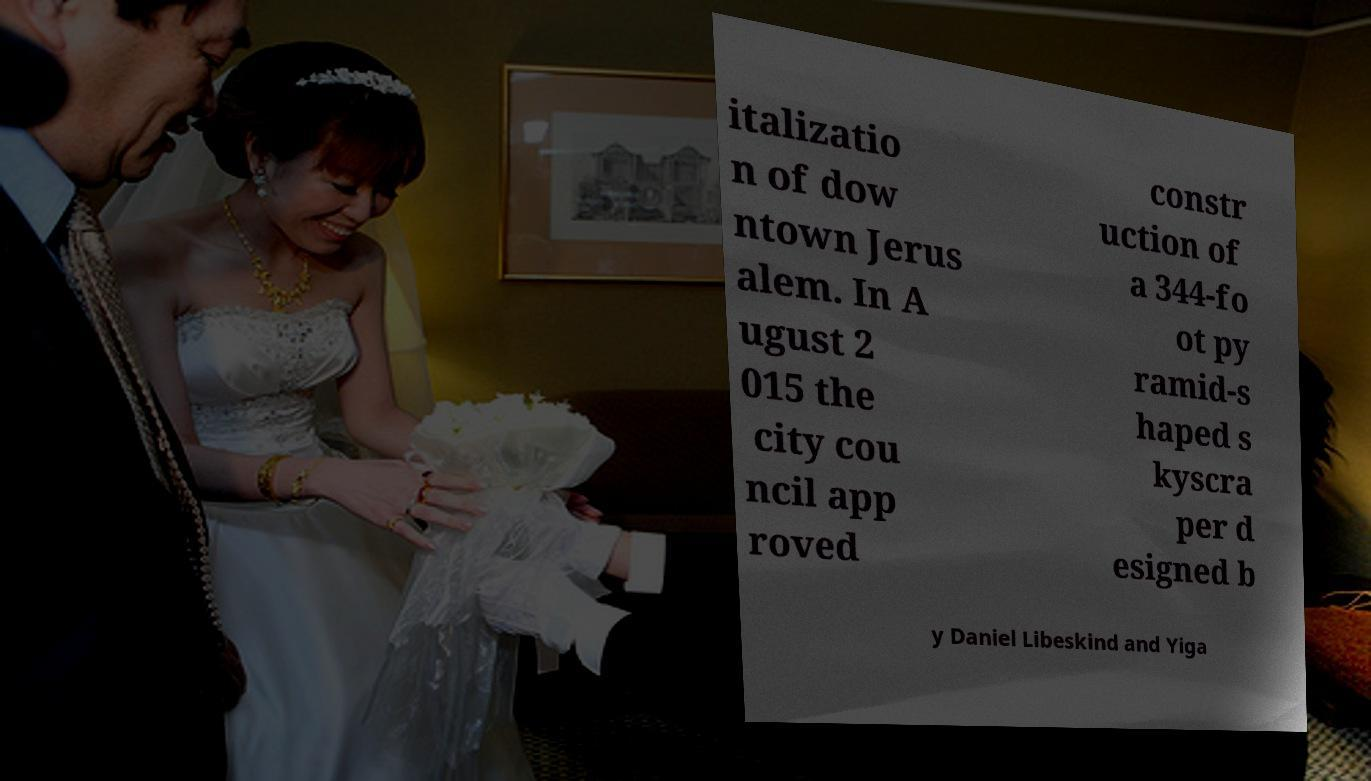Could you extract and type out the text from this image? italizatio n of dow ntown Jerus alem. In A ugust 2 015 the city cou ncil app roved constr uction of a 344-fo ot py ramid-s haped s kyscra per d esigned b y Daniel Libeskind and Yiga 